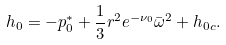Convert formula to latex. <formula><loc_0><loc_0><loc_500><loc_500>h _ { 0 } = - p _ { 0 } ^ { * } + \frac { 1 } { 3 } r ^ { 2 } e ^ { - \nu _ { 0 } } \bar { \omega } ^ { 2 } + h _ { 0 c } .</formula> 